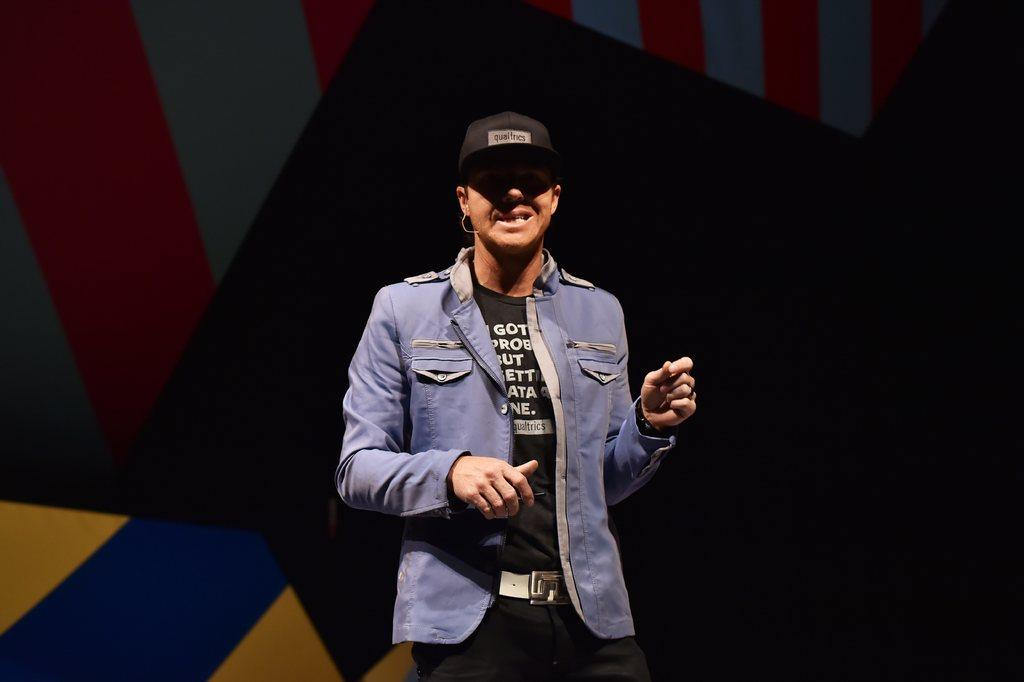What is the main subject of the image? There is a person standing in the image. Can you describe the background of the image? There is a wall behind the person in the image. Reasoning: Let'g: Let's think step by step in order to produce the conversation. We start by identifying the main subject of the image, which is the person standing. Then, we describe the background of the image, which is a wall. We avoid making any assumptions about the person's appearance or the wall's color or texture, as these details are not provided in the facts. Absurd Question/Answer: What type of hair can be seen on the person's head in the image? There is no information about the person's hair in the image, as the facts only mention that there is a person standing and a wall behind them. 